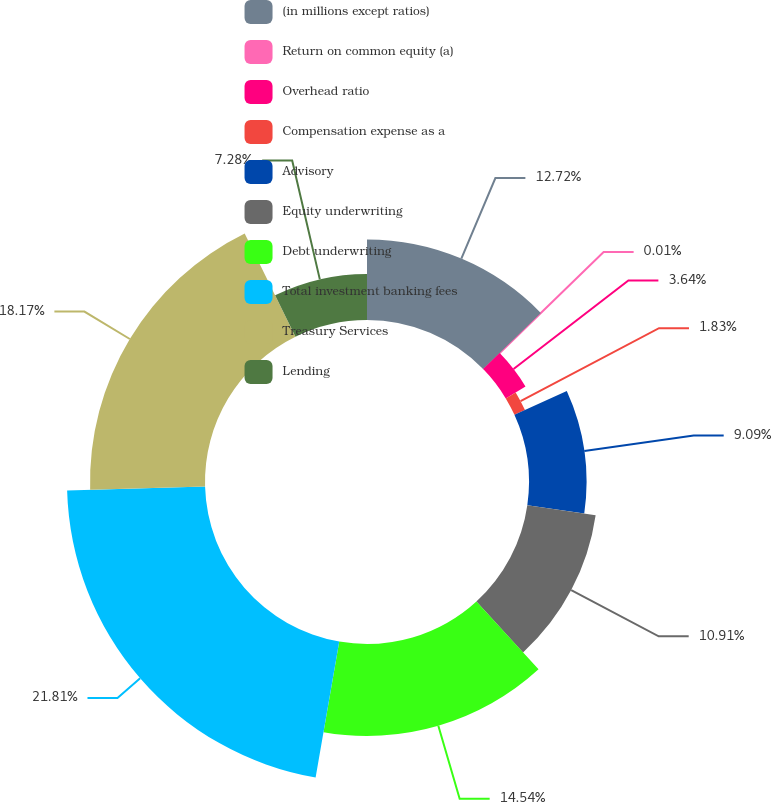<chart> <loc_0><loc_0><loc_500><loc_500><pie_chart><fcel>(in millions except ratios)<fcel>Return on common equity (a)<fcel>Overhead ratio<fcel>Compensation expense as a<fcel>Advisory<fcel>Equity underwriting<fcel>Debt underwriting<fcel>Total investment banking fees<fcel>Treasury Services<fcel>Lending<nl><fcel>12.72%<fcel>0.01%<fcel>3.64%<fcel>1.83%<fcel>9.09%<fcel>10.91%<fcel>14.54%<fcel>21.81%<fcel>18.17%<fcel>7.28%<nl></chart> 